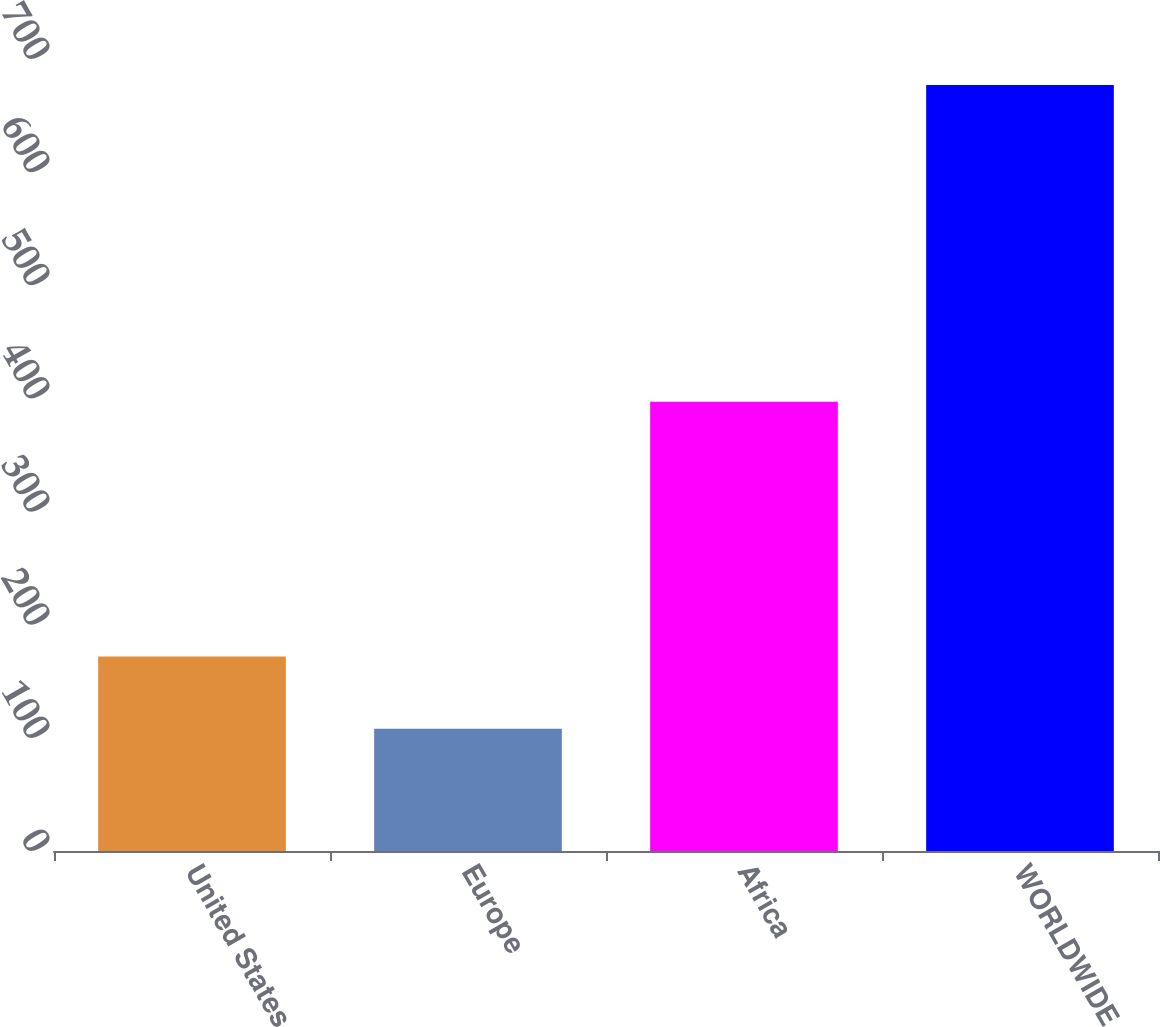Convert chart. <chart><loc_0><loc_0><loc_500><loc_500><bar_chart><fcel>United States<fcel>Europe<fcel>Africa<fcel>WORLDWIDE<nl><fcel>172<fcel>108<fcel>397<fcel>677<nl></chart> 